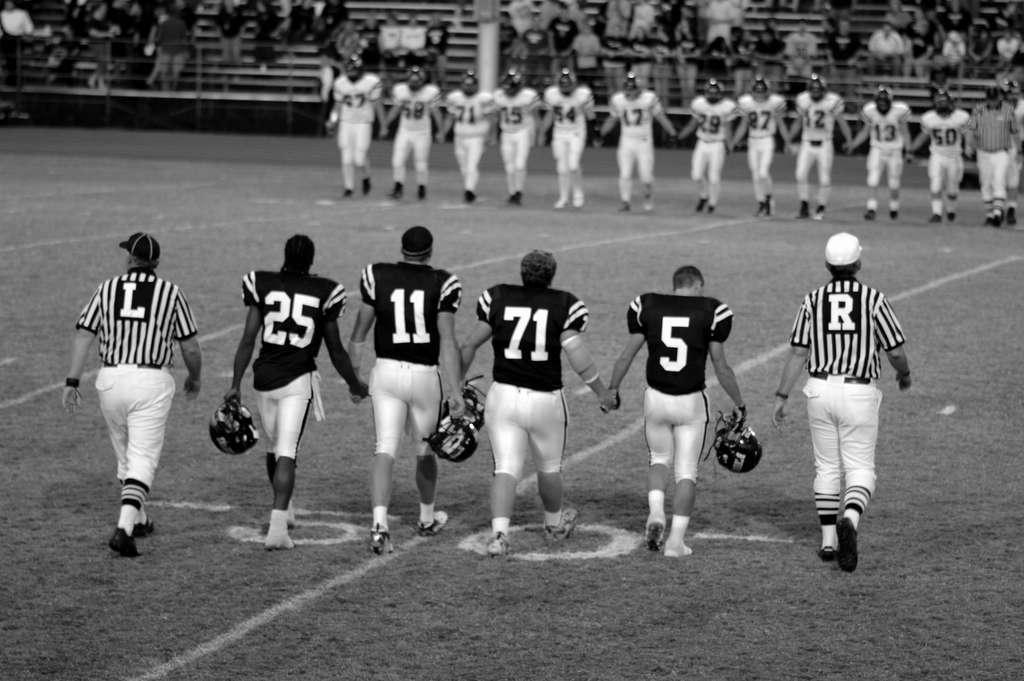Please provide a concise description of this image. This is a black and white image. In the foreground of the image there are people walking. In the background of the image there are people wearing helmets. At the bottom of the image there is grass. In the background of the image there are people sitting in stands. There is a fencing. 